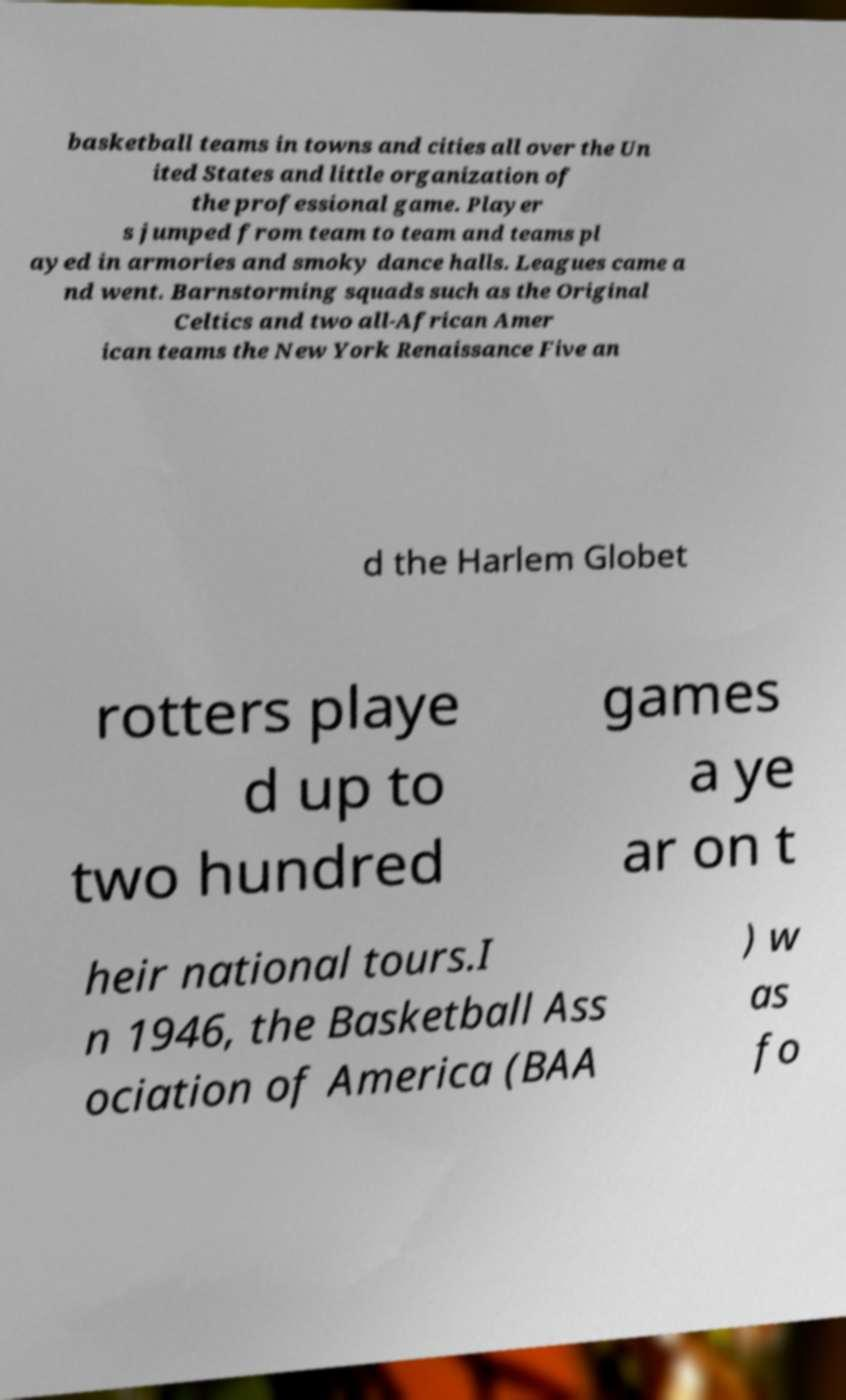Can you accurately transcribe the text from the provided image for me? basketball teams in towns and cities all over the Un ited States and little organization of the professional game. Player s jumped from team to team and teams pl ayed in armories and smoky dance halls. Leagues came a nd went. Barnstorming squads such as the Original Celtics and two all-African Amer ican teams the New York Renaissance Five an d the Harlem Globet rotters playe d up to two hundred games a ye ar on t heir national tours.I n 1946, the Basketball Ass ociation of America (BAA ) w as fo 